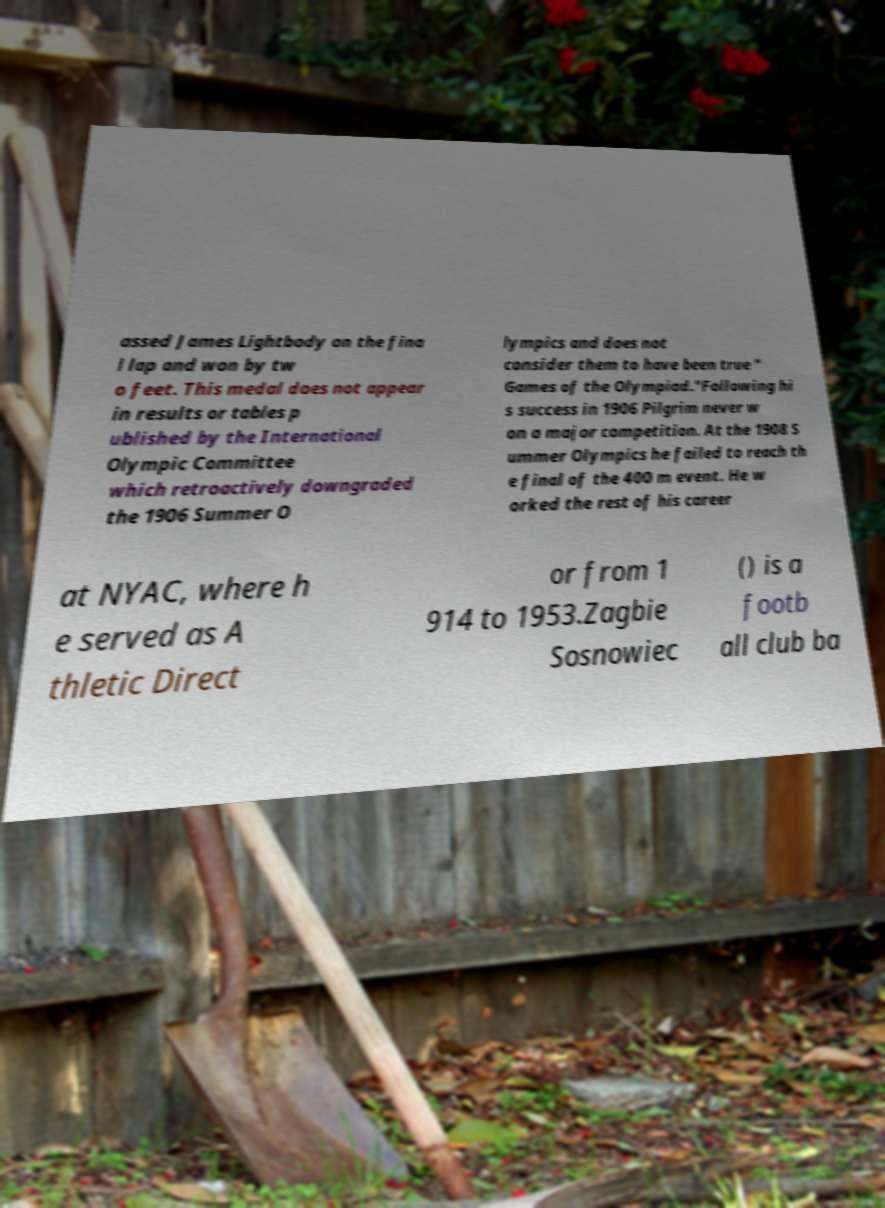Could you assist in decoding the text presented in this image and type it out clearly? assed James Lightbody on the fina l lap and won by tw o feet. This medal does not appear in results or tables p ublished by the International Olympic Committee which retroactively downgraded the 1906 Summer O lympics and does not consider them to have been true " Games of the Olympiad."Following hi s success in 1906 Pilgrim never w on a major competition. At the 1908 S ummer Olympics he failed to reach th e final of the 400 m event. He w orked the rest of his career at NYAC, where h e served as A thletic Direct or from 1 914 to 1953.Zagbie Sosnowiec () is a footb all club ba 